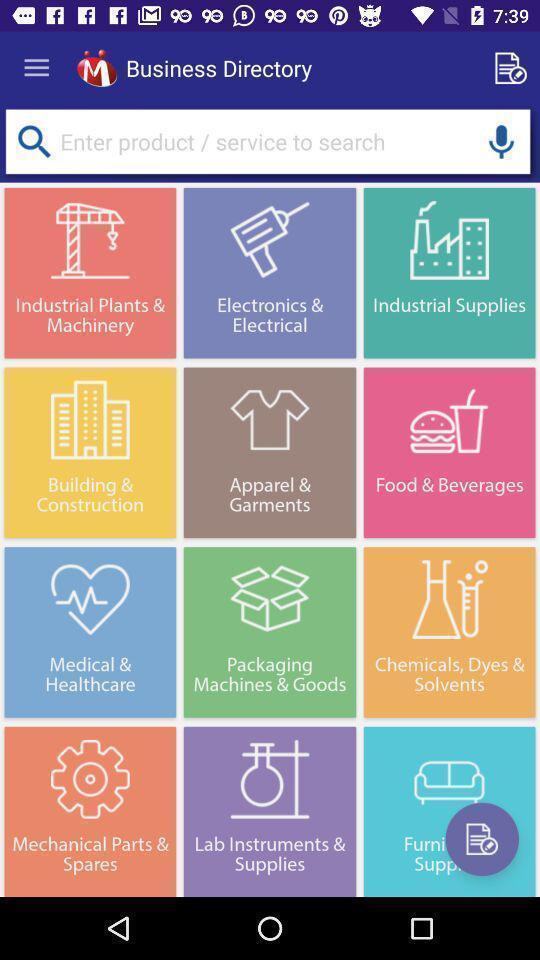Provide a description of this screenshot. Search bar for different business category. 